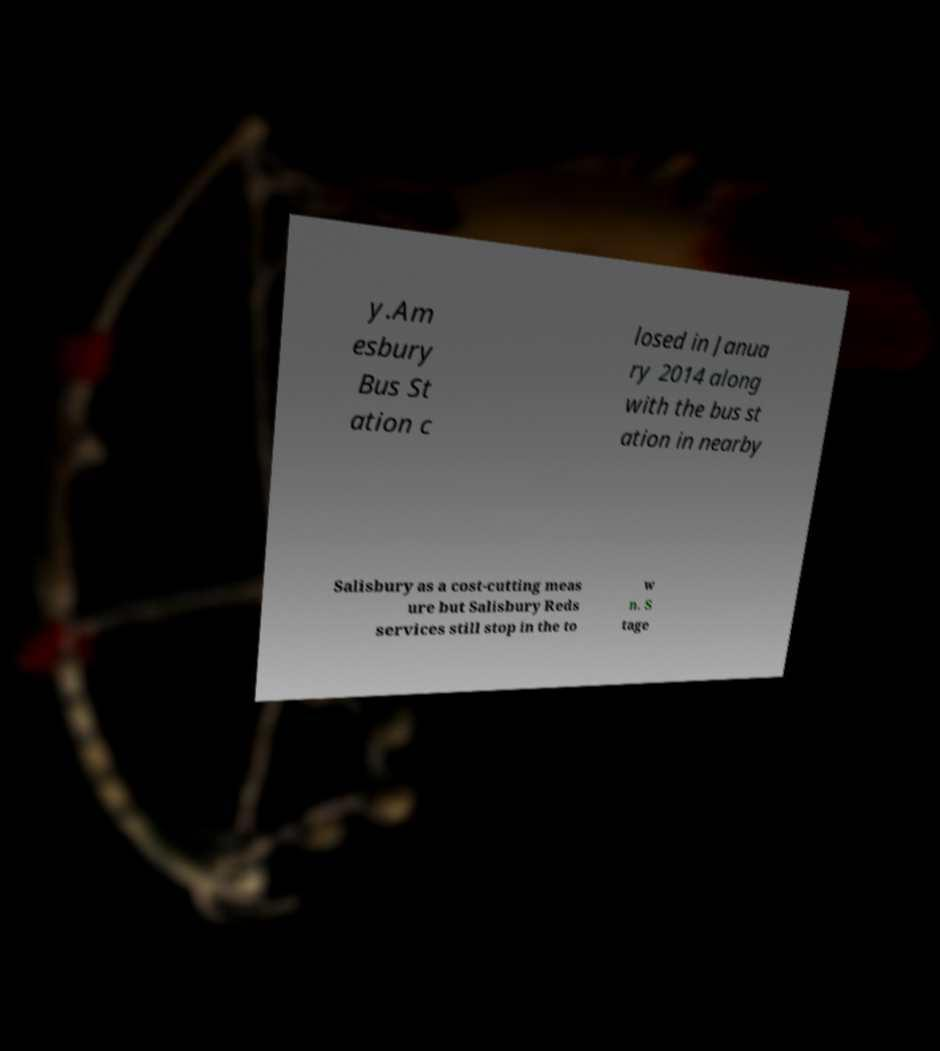Please identify and transcribe the text found in this image. y.Am esbury Bus St ation c losed in Janua ry 2014 along with the bus st ation in nearby Salisbury as a cost-cutting meas ure but Salisbury Reds services still stop in the to w n. S tage 